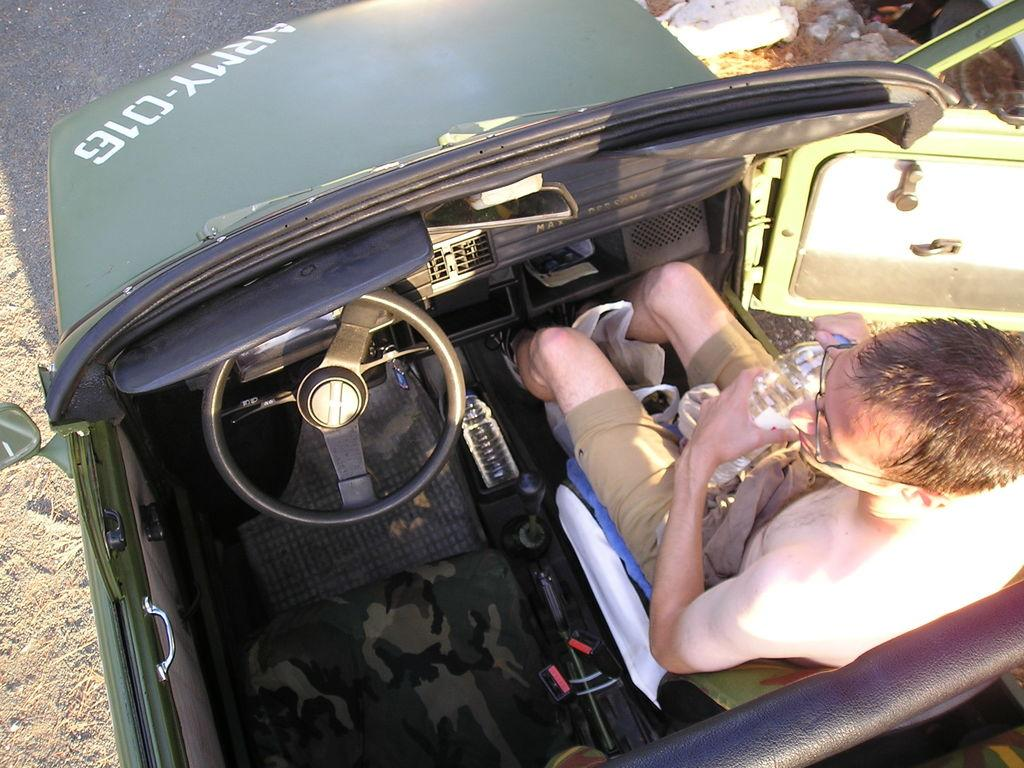What is the main subject of the image? There is a person in the image. What is the person doing in the image? The person is sitting in a car. Can you see any twigs in the image? There is no mention of twigs in the image, so we cannot determine if any are present. Is there any indication of slavery in the image? There is no indication of slavery in the image; it simply shows a person sitting in a car. 